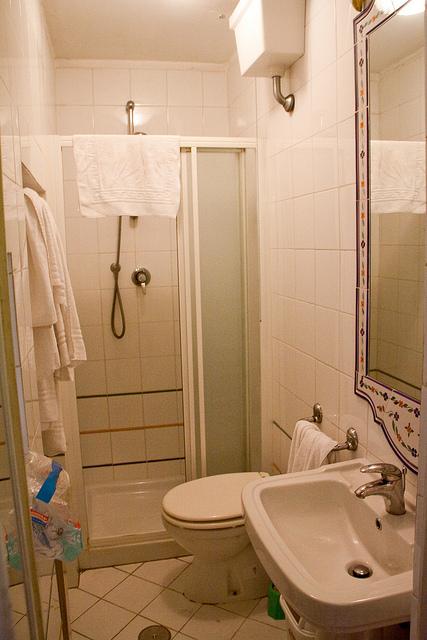Did somebody just take a shower?
Concise answer only. Yes. Is a shower shown?
Keep it brief. Yes. Is this a large bathroom?
Be succinct. No. What is the barrier next to the toilet made of?
Keep it brief. Glass. Does this look like a hotel bathroom?
Give a very brief answer. No. How many towels are there?
Concise answer only. 3. Are there any towels in this picture?
Give a very brief answer. Yes. What is reflected in the mirror?
Answer briefly. Towel. Is the towel fresh or used?
Quick response, please. Used. 